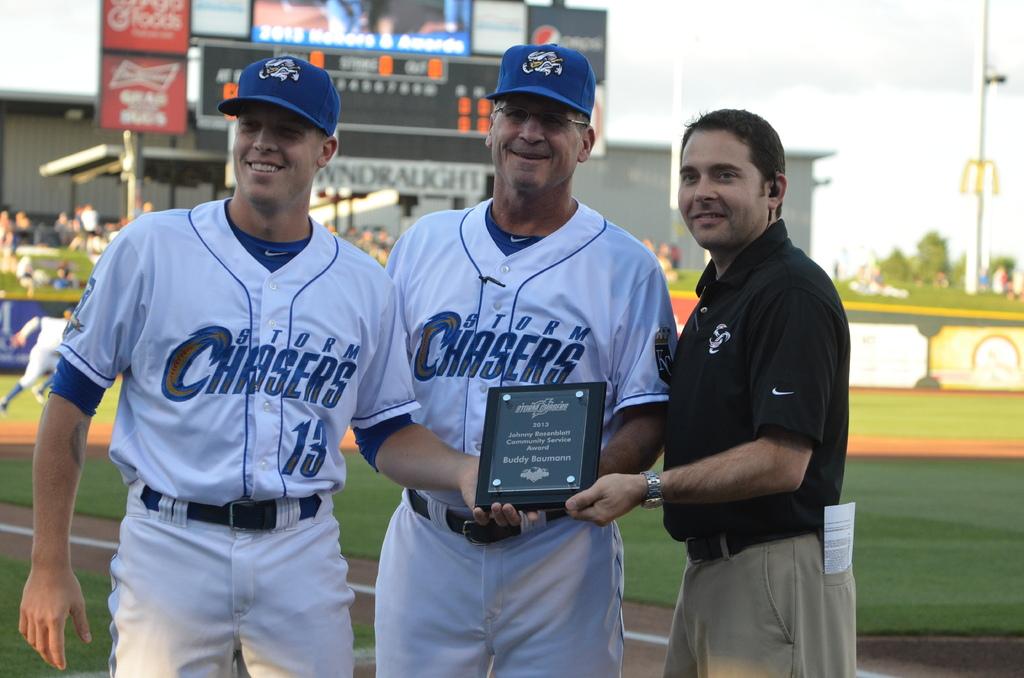What team is shown?
Make the answer very short. Storm chasers. 